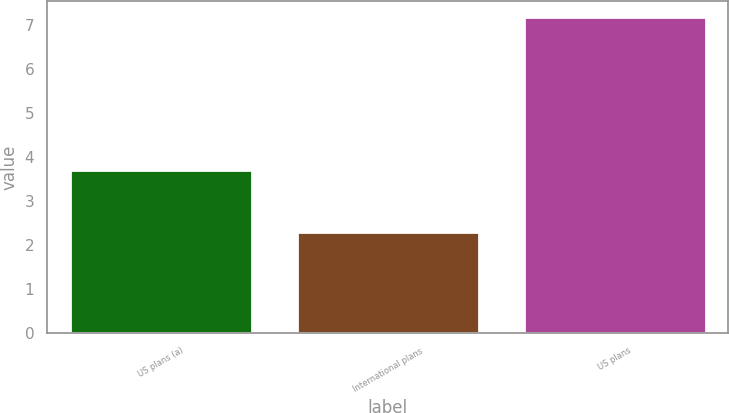Convert chart to OTSL. <chart><loc_0><loc_0><loc_500><loc_500><bar_chart><fcel>US plans (a)<fcel>International plans<fcel>US plans<nl><fcel>3.71<fcel>2.3<fcel>7.2<nl></chart> 